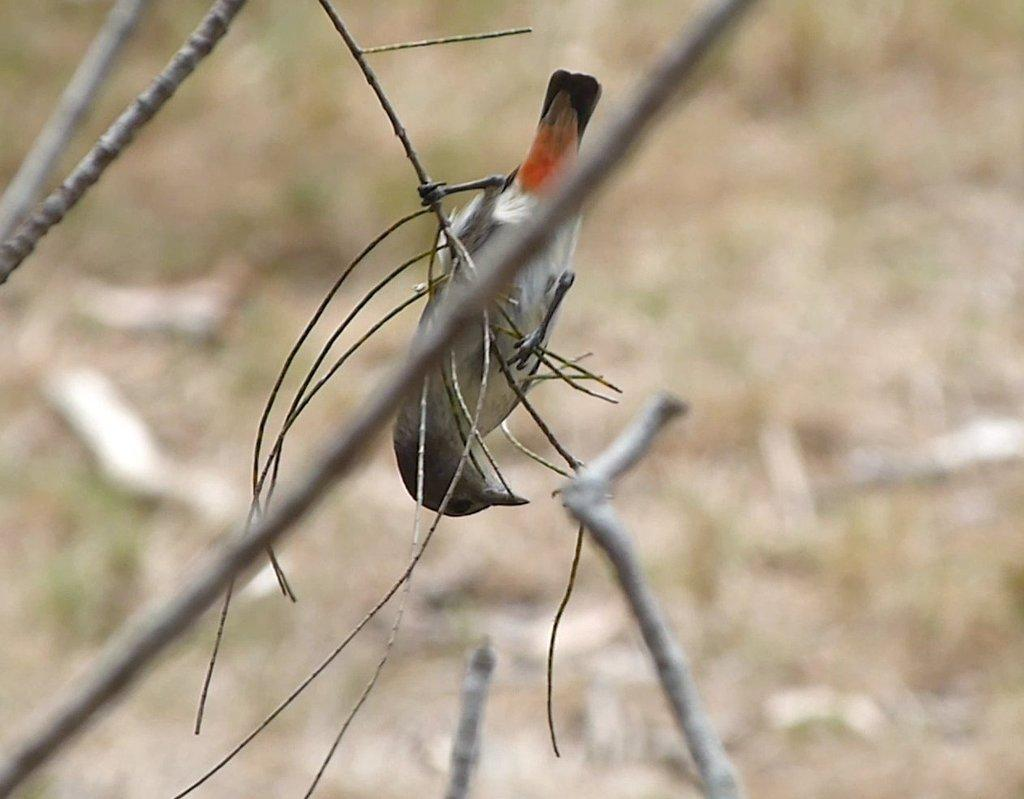What is the main subject in the foreground of the image? There is a bird in the foreground of the image. Where is the bird located? The bird is on a branch. What else can be seen in the foreground of the image? There are branches visible in the foreground. How would you describe the background of the image? The background of the image is blurred. Can you tell me how much profit the river generates in the image? There is no river present in the image, so it is not possible to determine any profit generated. 